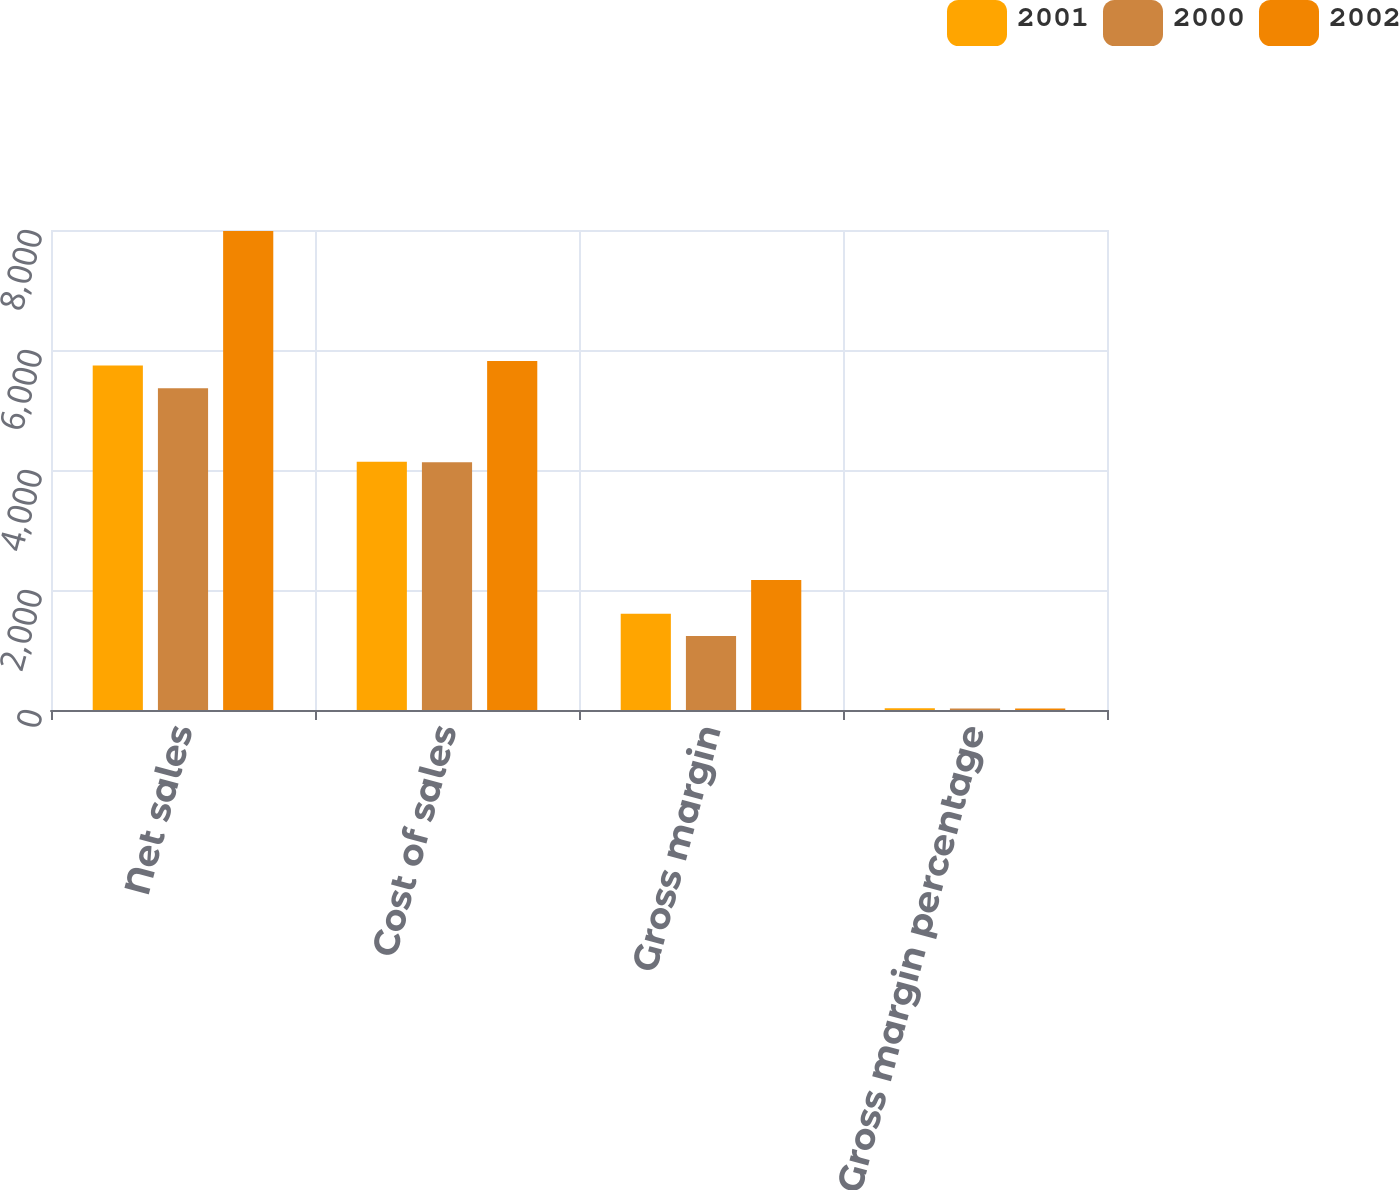Convert chart to OTSL. <chart><loc_0><loc_0><loc_500><loc_500><stacked_bar_chart><ecel><fcel>Net sales<fcel>Cost of sales<fcel>Gross margin<fcel>Gross margin percentage<nl><fcel>2001<fcel>5742<fcel>4139<fcel>1603<fcel>28<nl><fcel>2000<fcel>5363<fcel>4128<fcel>1235<fcel>23<nl><fcel>2002<fcel>7983<fcel>5817<fcel>2166<fcel>27<nl></chart> 